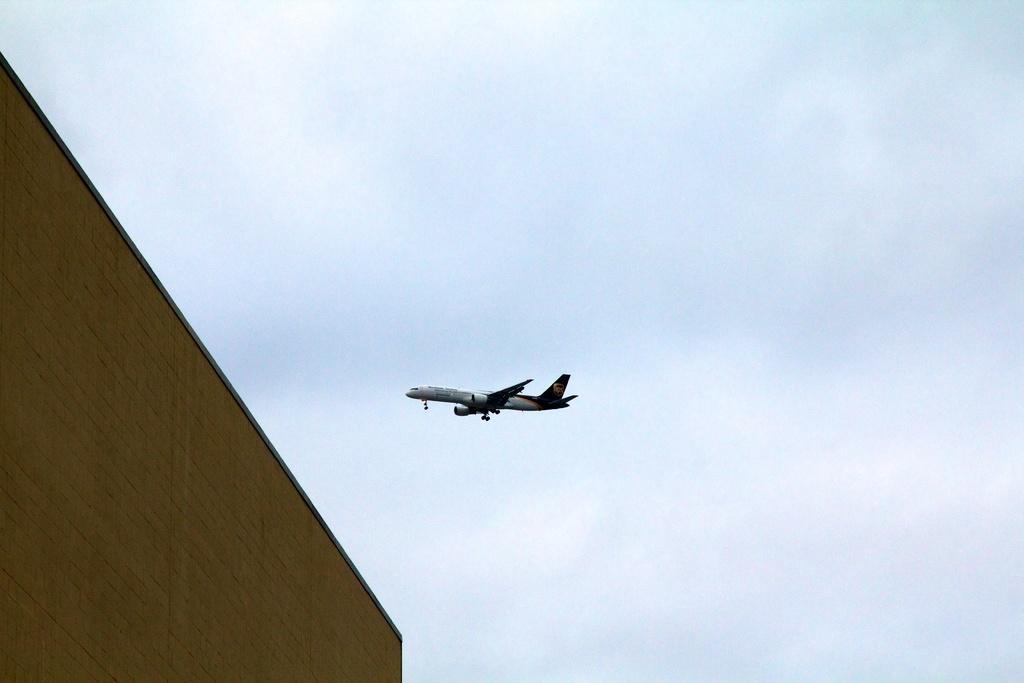How would you summarize this image in a sentence or two? In the center of the image, there is an aeroplane and on the left, there is a building. 